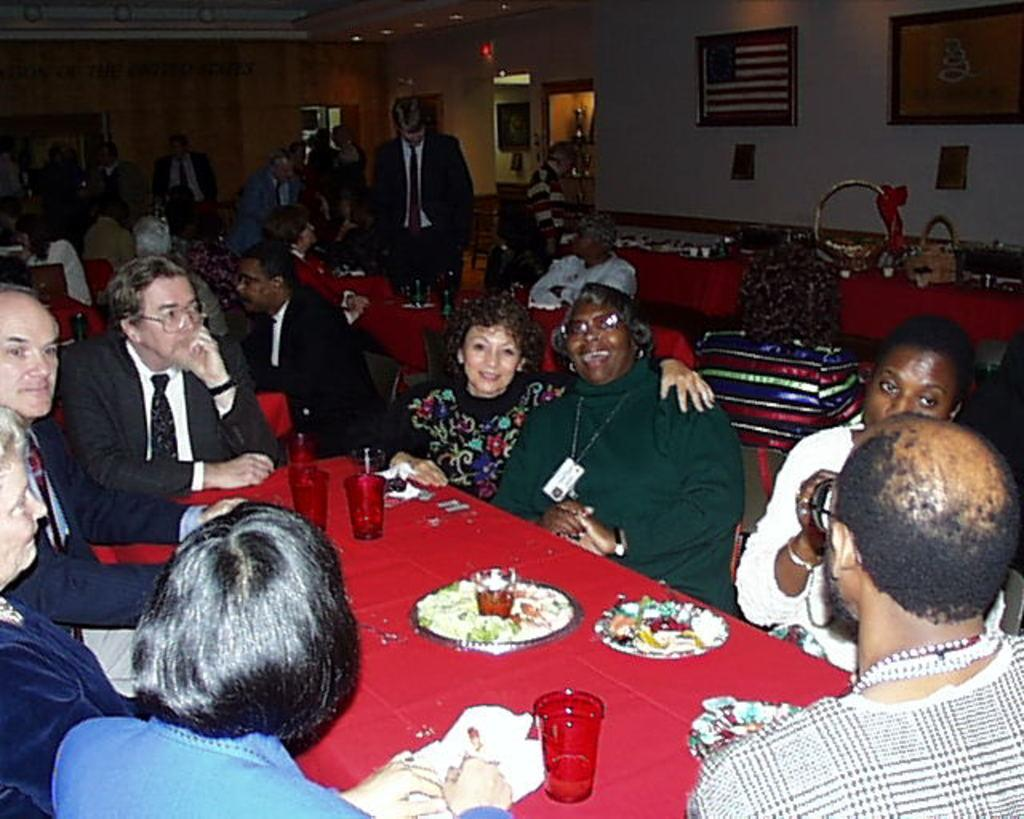How many people are in the image? There is a group of people in the image. What are the people doing in the image? The people are seated in the image. What is in front of the people? There is a table in front of the people. What items can be seen on the table? Glasses and plates are present on the table. What type of power source is visible in the image? There is no power source visible in the image. Can you see any badges on the people in the image? There is no mention of badges in the provided facts, so we cannot determine if any are present. 